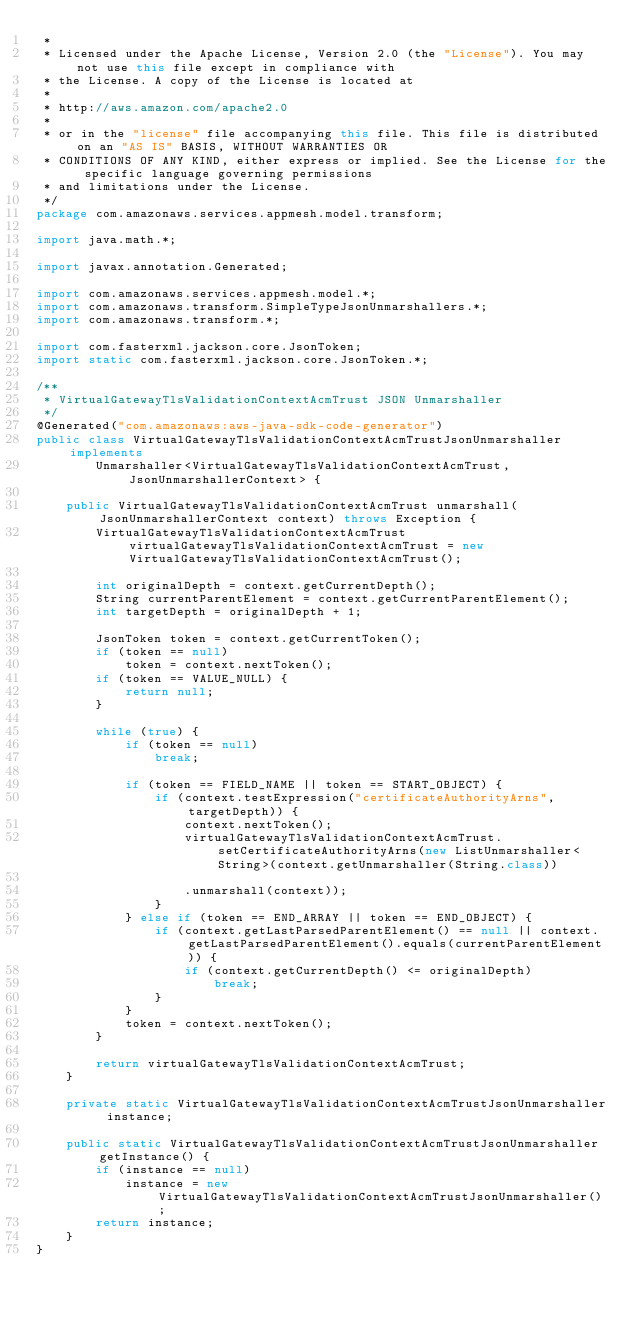<code> <loc_0><loc_0><loc_500><loc_500><_Java_> * 
 * Licensed under the Apache License, Version 2.0 (the "License"). You may not use this file except in compliance with
 * the License. A copy of the License is located at
 * 
 * http://aws.amazon.com/apache2.0
 * 
 * or in the "license" file accompanying this file. This file is distributed on an "AS IS" BASIS, WITHOUT WARRANTIES OR
 * CONDITIONS OF ANY KIND, either express or implied. See the License for the specific language governing permissions
 * and limitations under the License.
 */
package com.amazonaws.services.appmesh.model.transform;

import java.math.*;

import javax.annotation.Generated;

import com.amazonaws.services.appmesh.model.*;
import com.amazonaws.transform.SimpleTypeJsonUnmarshallers.*;
import com.amazonaws.transform.*;

import com.fasterxml.jackson.core.JsonToken;
import static com.fasterxml.jackson.core.JsonToken.*;

/**
 * VirtualGatewayTlsValidationContextAcmTrust JSON Unmarshaller
 */
@Generated("com.amazonaws:aws-java-sdk-code-generator")
public class VirtualGatewayTlsValidationContextAcmTrustJsonUnmarshaller implements
        Unmarshaller<VirtualGatewayTlsValidationContextAcmTrust, JsonUnmarshallerContext> {

    public VirtualGatewayTlsValidationContextAcmTrust unmarshall(JsonUnmarshallerContext context) throws Exception {
        VirtualGatewayTlsValidationContextAcmTrust virtualGatewayTlsValidationContextAcmTrust = new VirtualGatewayTlsValidationContextAcmTrust();

        int originalDepth = context.getCurrentDepth();
        String currentParentElement = context.getCurrentParentElement();
        int targetDepth = originalDepth + 1;

        JsonToken token = context.getCurrentToken();
        if (token == null)
            token = context.nextToken();
        if (token == VALUE_NULL) {
            return null;
        }

        while (true) {
            if (token == null)
                break;

            if (token == FIELD_NAME || token == START_OBJECT) {
                if (context.testExpression("certificateAuthorityArns", targetDepth)) {
                    context.nextToken();
                    virtualGatewayTlsValidationContextAcmTrust.setCertificateAuthorityArns(new ListUnmarshaller<String>(context.getUnmarshaller(String.class))

                    .unmarshall(context));
                }
            } else if (token == END_ARRAY || token == END_OBJECT) {
                if (context.getLastParsedParentElement() == null || context.getLastParsedParentElement().equals(currentParentElement)) {
                    if (context.getCurrentDepth() <= originalDepth)
                        break;
                }
            }
            token = context.nextToken();
        }

        return virtualGatewayTlsValidationContextAcmTrust;
    }

    private static VirtualGatewayTlsValidationContextAcmTrustJsonUnmarshaller instance;

    public static VirtualGatewayTlsValidationContextAcmTrustJsonUnmarshaller getInstance() {
        if (instance == null)
            instance = new VirtualGatewayTlsValidationContextAcmTrustJsonUnmarshaller();
        return instance;
    }
}
</code> 